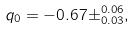<formula> <loc_0><loc_0><loc_500><loc_500>q _ { 0 } = - 0 . 6 7 \pm ^ { 0 . 0 6 } _ { 0 . 0 3 } ,</formula> 